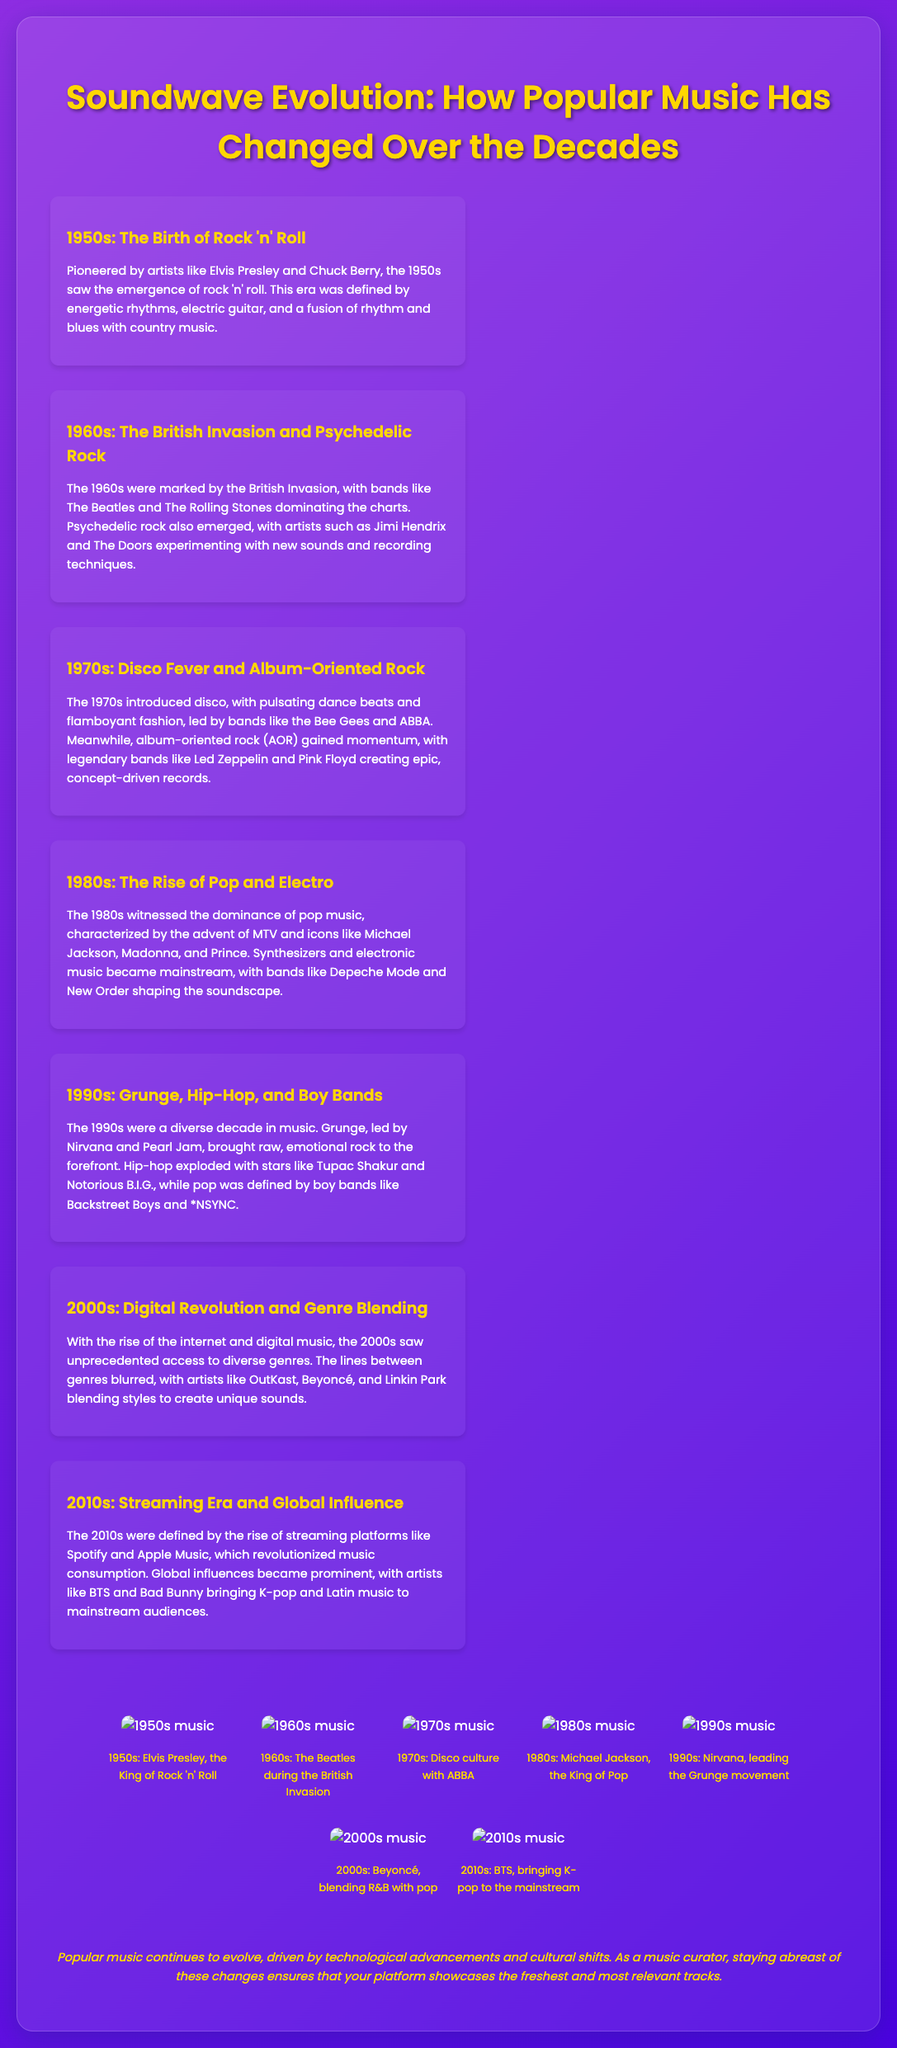What genre was pioneered by Elvis Presley? The document states that the 1950s saw the emergence of rock 'n' roll, pioneered by Elvis Presley.
Answer: rock 'n' roll Which band is associated with the British Invasion? The document mentions The Beatles as a key band during the British Invasion in the 1960s.
Answer: The Beatles What music style became mainstream in the 1980s? The document states that synthesizers and electronic music became mainstream in the 1980s.
Answer: electronic music Which decade is characterized by the rise of streaming platforms? The document indicates that the 2010s were defined by the rise of streaming platforms like Spotify and Apple Music.
Answer: 2010s Who was mentioned as leading the grunge movement? According to the document, Nirvana is mentioned as leading the grunge movement in the 1990s.
Answer: Nirvana What defining feature marked the 1970s music scene? The document highlights disco as a defining feature of the 1970s music scene.
Answer: disco Which artist blended R&B with pop in the 2000s? The document states that Beyoncé was known for blending R&B with pop in the 2000s.
Answer: Beyoncé What cultural shift is noted in the conclusion? The conclusion mentions that popular music continues to evolve driven by technological advancements and cultural shifts.
Answer: cultural shifts How did the visuals contribute to the document? The visuals enhance the document by providing images that represent significant artists from each decade.
Answer: images of significant artists 